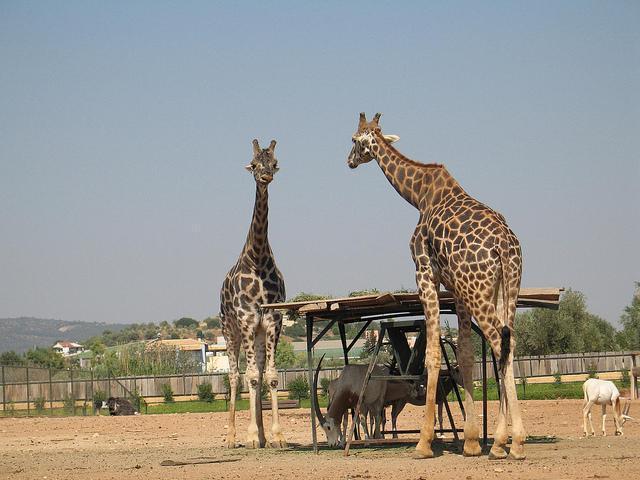How many giraffes are visible?
Give a very brief answer. 2. 